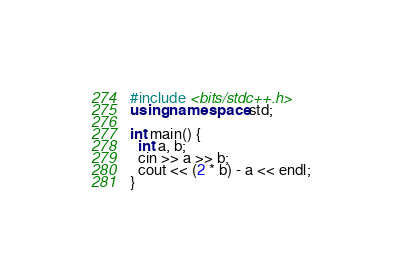Convert code to text. <code><loc_0><loc_0><loc_500><loc_500><_C++_>#include <bits/stdc++.h>
using namespace std;
 
int main() {
  int a, b;
  cin >> a >> b;
  cout << (2 * b) - a << endl;
}</code> 